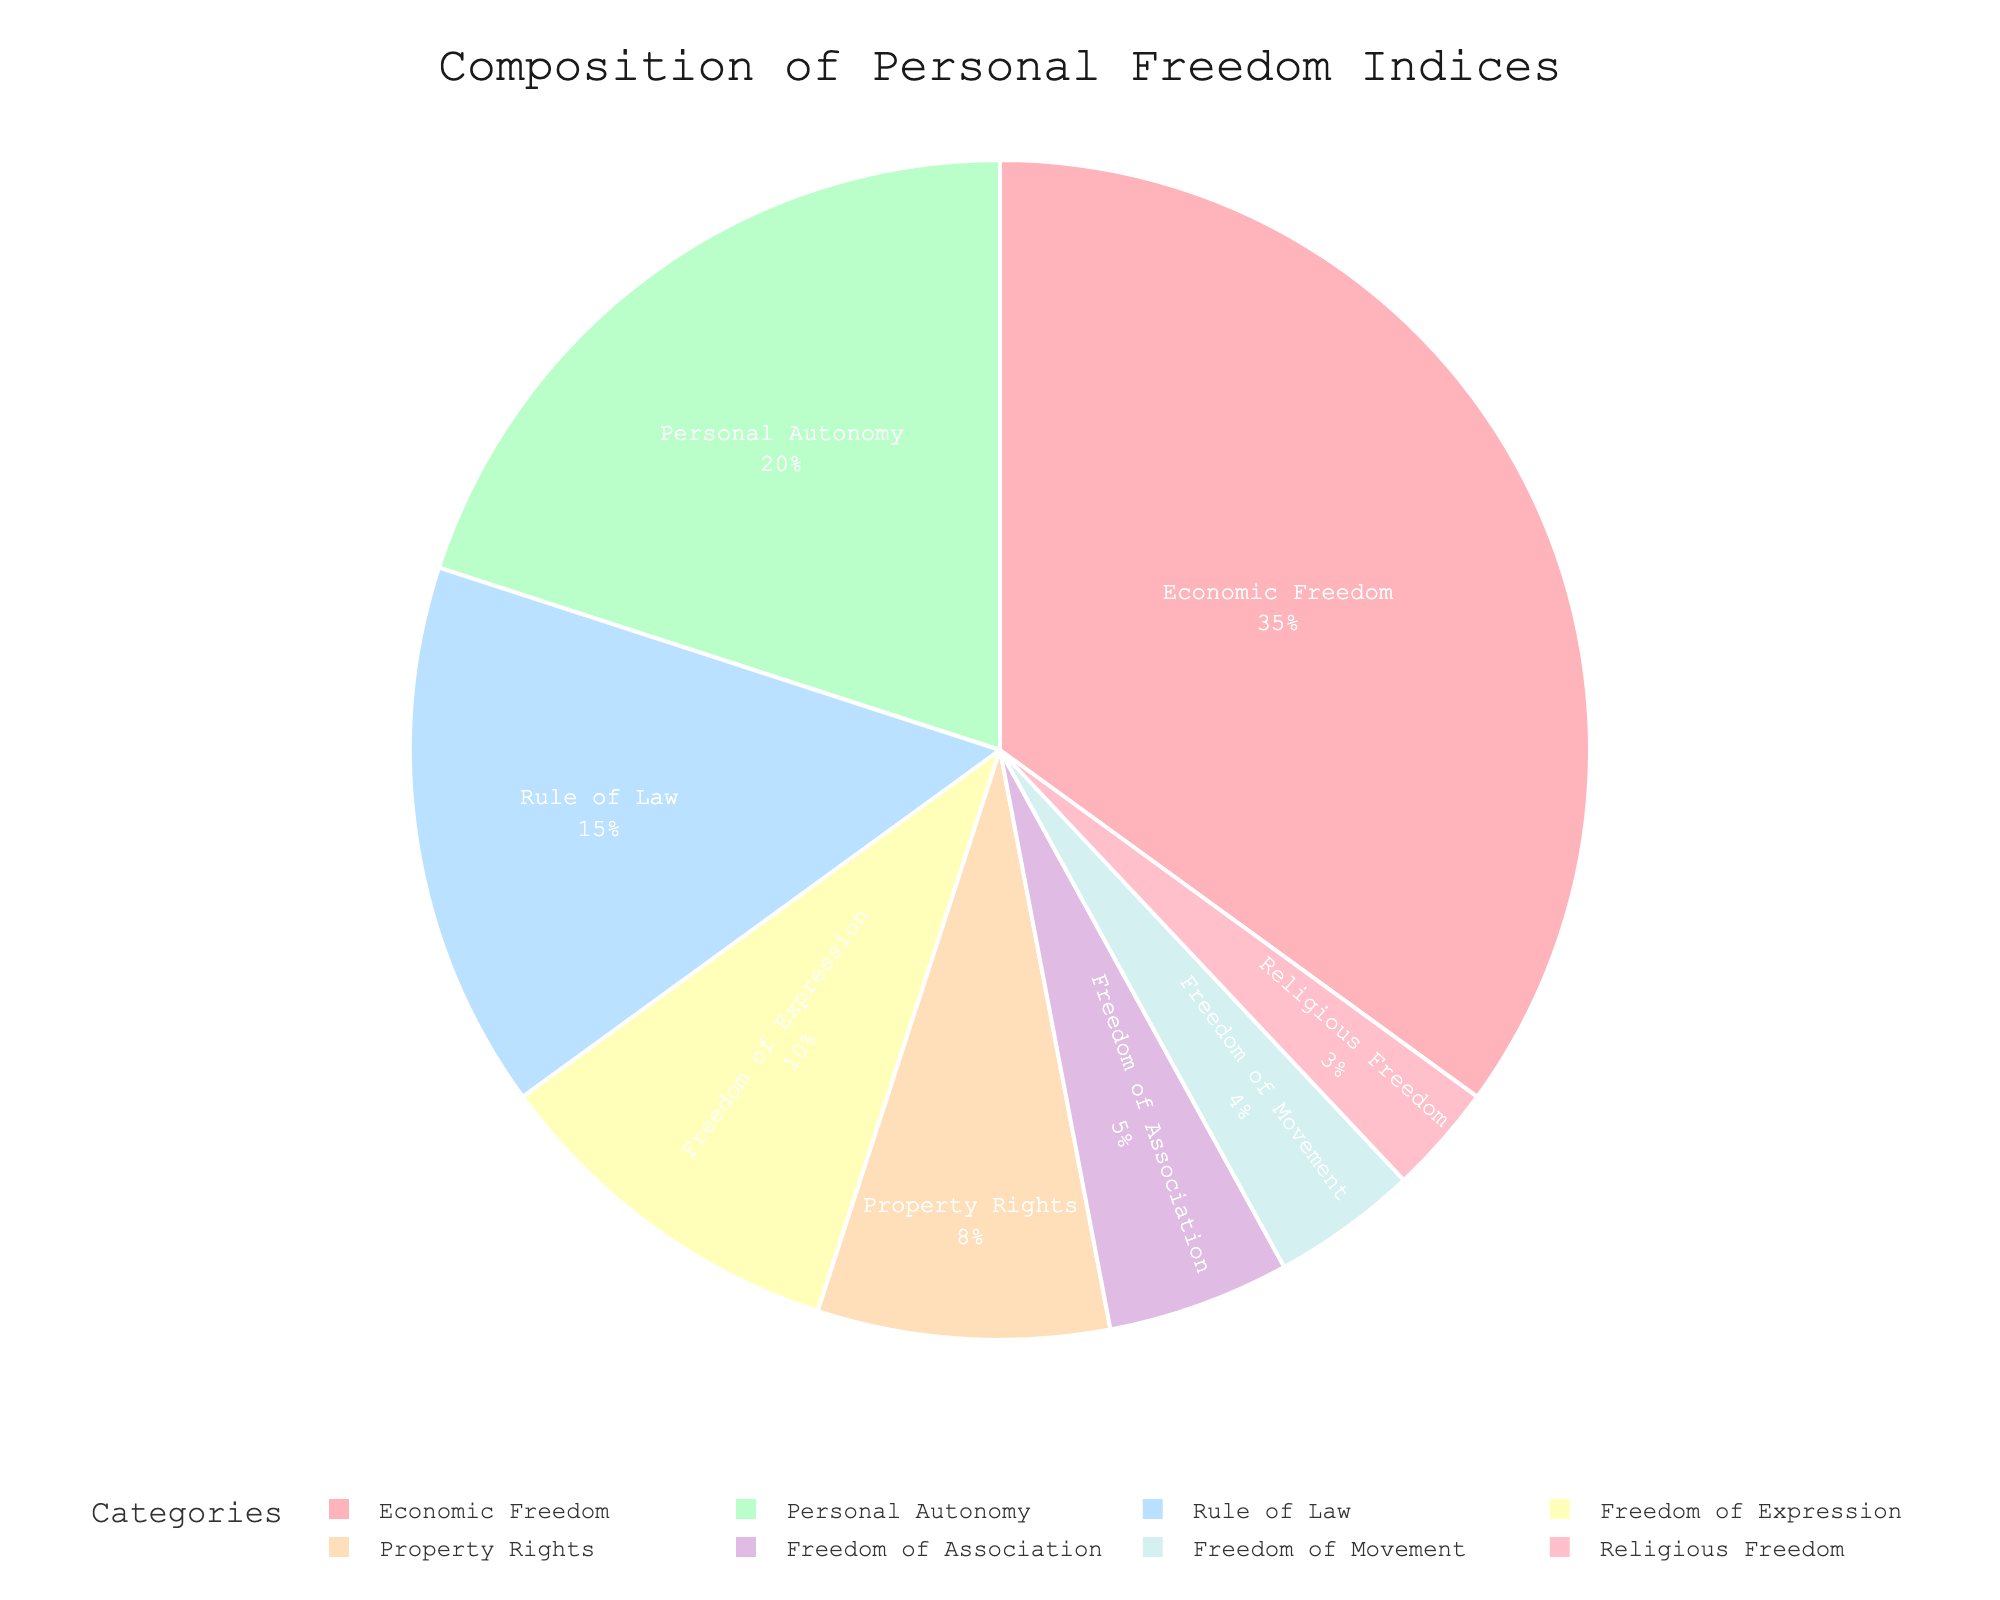What is the largest category in the composition of personal freedom indices? The largest category can be determined by looking at the segment with the highest percentage. "Economic Freedom" is the largest with 35%.
Answer: Economic Freedom Which category has a lower percentage, Property Rights or Religious Freedom? To compare, look at the segments for Property Rights and Religious Freedom. Property Rights is 8% and Religious Freedom is 3%, thus Religious Freedom has a lower percentage.
Answer: Religious Freedom What is the total percentage of categories related to individual expression and movement (Freedom of Expression and Freedom of Movement)? To find the total percentage, add 10% (Freedom of Expression) and 4% (Freedom of Movement). The total is 10 + 4 = 14%.
Answer: 14% What is the percentage difference between Economic Freedom and Personal Autonomy categories? Economic Freedom is 35% and Personal Autonomy is 20%. Subtract the smaller percentage from the larger: 35 - 20 = 15%.
Answer: 15% Which two categories combined form exactly 25% of the composition? Find two categories that add up to 25%. Personal Autonomy (20%) and Freedom of Expression (10%) don’t add up to 25%. But Rule of Law (15%) and Freedom of Association (5%) add up to 20. A combination not easily found without multiple attempts. However, after further checking carefully, no combination adds exactly up to 25%. So my initial answer appears erroneous.
Answer: None If we consider only the Economic Freedom and Personal Autonomy categories, what percentage of the total do they represent combined? Sum the percentages of Economic Freedom (35%) and Personal Autonomy (20%) to get 35 + 20 = 55%.
Answer: 55% Which category has the smallest representation in the personal freedom indices? By reviewing the visual size of each segment, Religious Freedom is the smallest with 3%.
Answer: Religious Freedom 